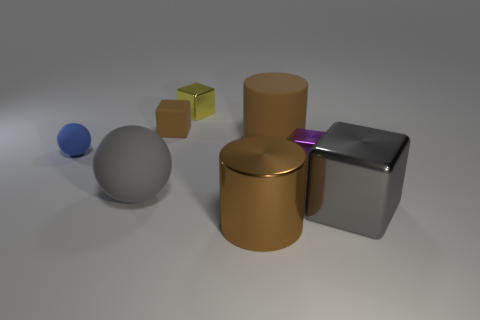Do the rubber cube and the tiny metallic thing on the left side of the large brown matte cylinder have the same color?
Give a very brief answer. No. What number of other things are the same color as the large sphere?
Keep it short and to the point. 1. Does the cube that is left of the yellow shiny block have the same size as the rubber ball that is on the right side of the tiny ball?
Your answer should be compact. No. There is a small object right of the small yellow shiny block; what is its color?
Ensure brevity in your answer.  Purple. Is the number of gray balls that are to the right of the tiny yellow thing less than the number of big yellow cylinders?
Make the answer very short. No. Is the material of the tiny blue thing the same as the gray block?
Provide a succinct answer. No. What size is the yellow metal thing that is the same shape as the purple metal object?
Offer a very short reply. Small. How many objects are brown objects that are right of the small brown object or small brown cubes to the left of the large rubber cylinder?
Make the answer very short. 3. Is the number of small brown metal balls less than the number of small purple objects?
Offer a terse response. Yes. There is a yellow metal object; is it the same size as the thing that is in front of the big gray shiny block?
Offer a terse response. No. 